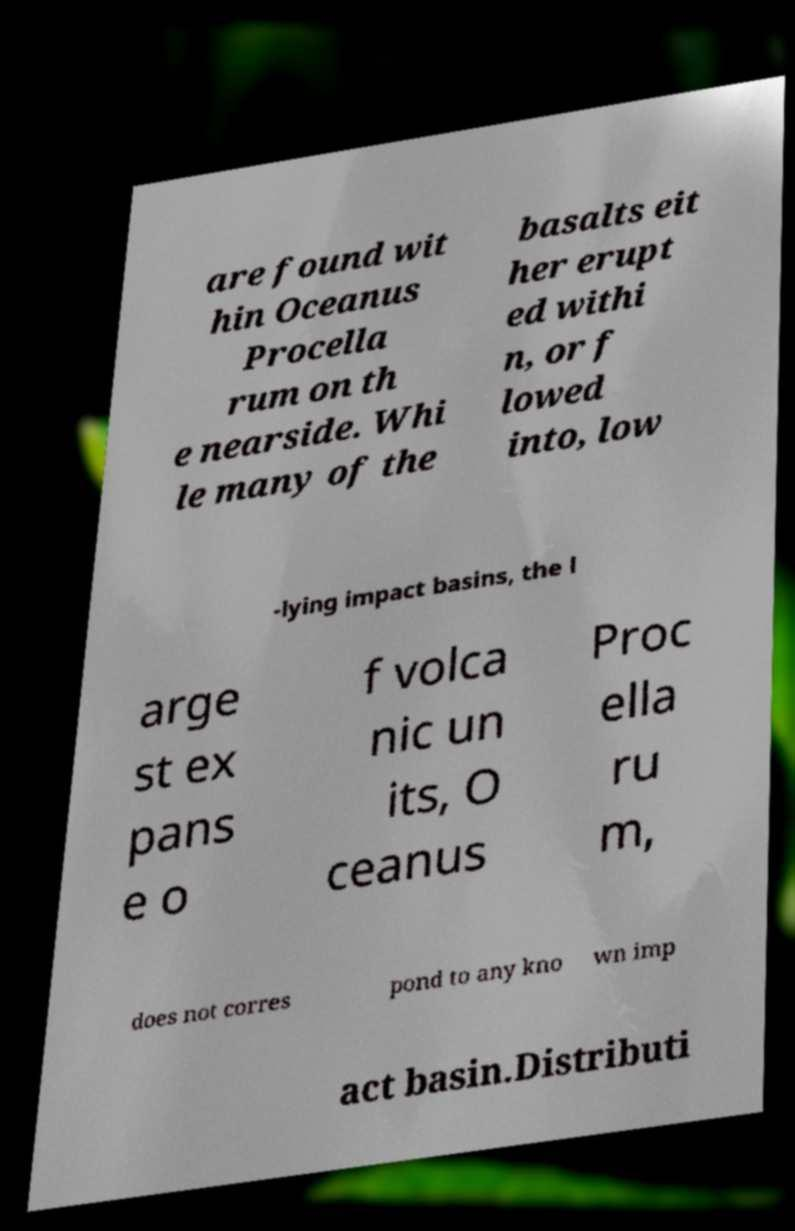Please identify and transcribe the text found in this image. are found wit hin Oceanus Procella rum on th e nearside. Whi le many of the basalts eit her erupt ed withi n, or f lowed into, low -lying impact basins, the l arge st ex pans e o f volca nic un its, O ceanus Proc ella ru m, does not corres pond to any kno wn imp act basin.Distributi 